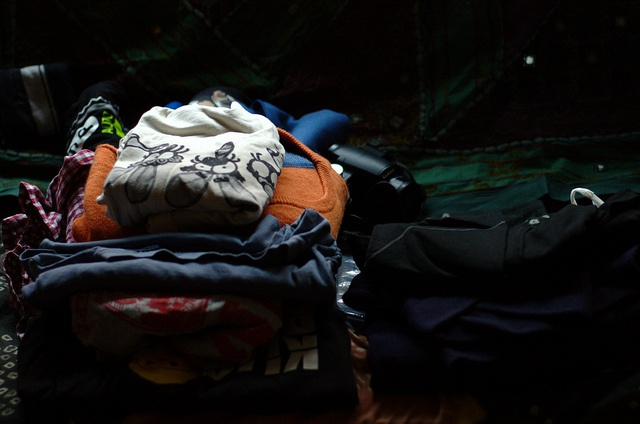Describe the objects in this image and their specific colors. I can see handbag in black, gray, darkgray, and purple tones and handbag in black, ivory, darkgray, and gray tones in this image. 